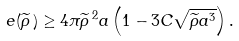<formula> <loc_0><loc_0><loc_500><loc_500>e ( \widetilde { \rho } \, ) \geq 4 \pi \widetilde { \rho } \, ^ { 2 } a \left ( 1 - 3 C \sqrt { \widetilde { \rho } a ^ { 3 } } \right ) .</formula> 